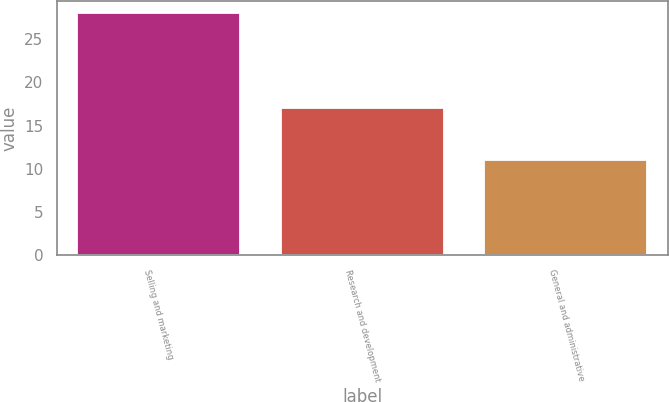Convert chart. <chart><loc_0><loc_0><loc_500><loc_500><bar_chart><fcel>Selling and marketing<fcel>Research and development<fcel>General and administrative<nl><fcel>28<fcel>17<fcel>11<nl></chart> 